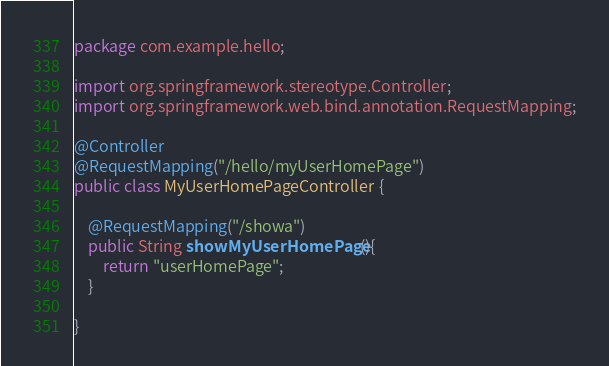Convert code to text. <code><loc_0><loc_0><loc_500><loc_500><_Java_>package com.example.hello;

import org.springframework.stereotype.Controller;
import org.springframework.web.bind.annotation.RequestMapping;

@Controller
@RequestMapping("/hello/myUserHomePage")
public class MyUserHomePageController {
	
	@RequestMapping("/showa")
	public String showMyUserHomePage(){
		return "userHomePage";
	}

}
</code> 